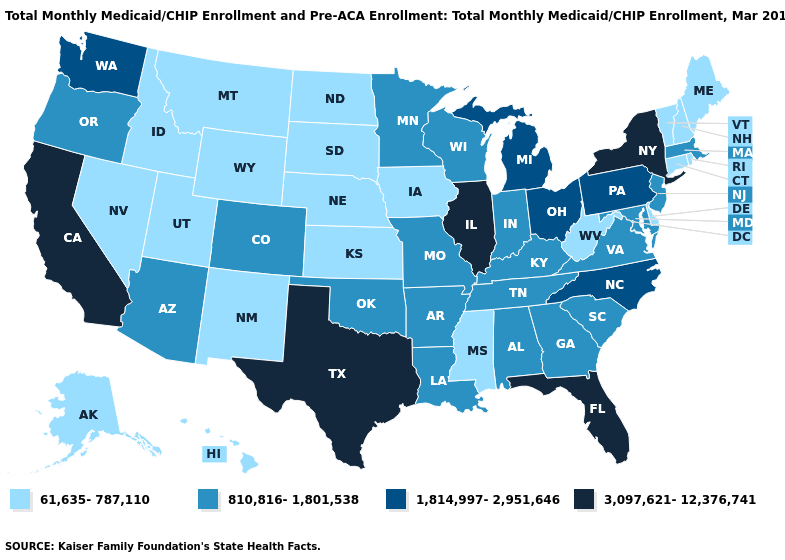Name the states that have a value in the range 1,814,997-2,951,646?
Answer briefly. Michigan, North Carolina, Ohio, Pennsylvania, Washington. Which states have the highest value in the USA?
Answer briefly. California, Florida, Illinois, New York, Texas. Does South Carolina have the same value as Virginia?
Write a very short answer. Yes. Does Nebraska have the lowest value in the USA?
Short answer required. Yes. Does Maryland have the lowest value in the South?
Write a very short answer. No. Which states have the lowest value in the Northeast?
Quick response, please. Connecticut, Maine, New Hampshire, Rhode Island, Vermont. Which states hav the highest value in the Northeast?
Write a very short answer. New York. Does Maryland have the highest value in the South?
Concise answer only. No. What is the value of Alaska?
Be succinct. 61,635-787,110. What is the value of Mississippi?
Short answer required. 61,635-787,110. What is the highest value in the Northeast ?
Be succinct. 3,097,621-12,376,741. Does Wisconsin have the lowest value in the MidWest?
Give a very brief answer. No. Which states have the highest value in the USA?
Answer briefly. California, Florida, Illinois, New York, Texas. Does Illinois have the highest value in the USA?
Keep it brief. Yes. Name the states that have a value in the range 1,814,997-2,951,646?
Write a very short answer. Michigan, North Carolina, Ohio, Pennsylvania, Washington. 